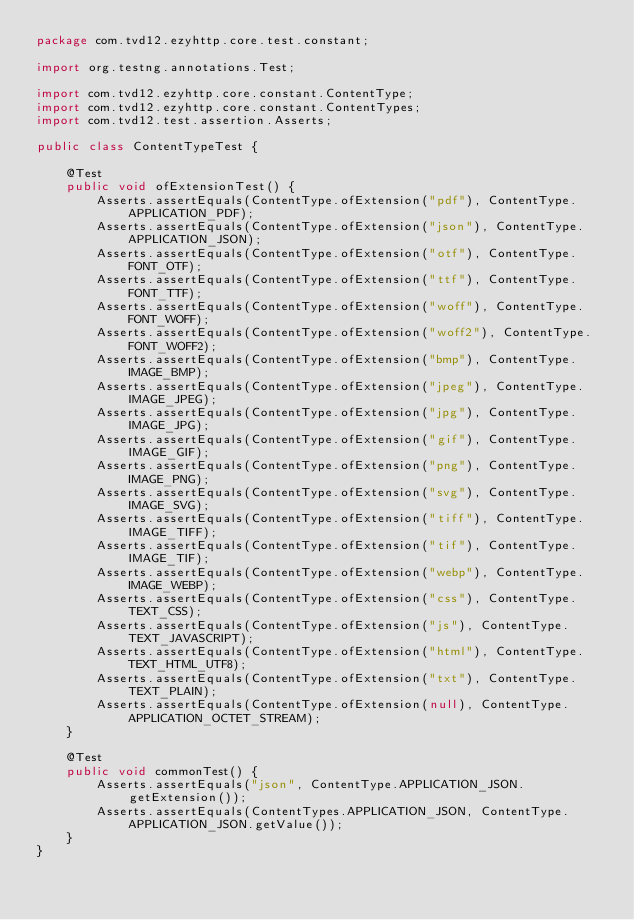Convert code to text. <code><loc_0><loc_0><loc_500><loc_500><_Java_>package com.tvd12.ezyhttp.core.test.constant;

import org.testng.annotations.Test;

import com.tvd12.ezyhttp.core.constant.ContentType;
import com.tvd12.ezyhttp.core.constant.ContentTypes;
import com.tvd12.test.assertion.Asserts;

public class ContentTypeTest {

    @Test
    public void ofExtensionTest() {
        Asserts.assertEquals(ContentType.ofExtension("pdf"), ContentType.APPLICATION_PDF);
        Asserts.assertEquals(ContentType.ofExtension("json"), ContentType.APPLICATION_JSON);
        Asserts.assertEquals(ContentType.ofExtension("otf"), ContentType.FONT_OTF);
        Asserts.assertEquals(ContentType.ofExtension("ttf"), ContentType.FONT_TTF);
        Asserts.assertEquals(ContentType.ofExtension("woff"), ContentType.FONT_WOFF);
        Asserts.assertEquals(ContentType.ofExtension("woff2"), ContentType.FONT_WOFF2);
        Asserts.assertEquals(ContentType.ofExtension("bmp"), ContentType.IMAGE_BMP);
        Asserts.assertEquals(ContentType.ofExtension("jpeg"), ContentType.IMAGE_JPEG);
        Asserts.assertEquals(ContentType.ofExtension("jpg"), ContentType.IMAGE_JPG);
        Asserts.assertEquals(ContentType.ofExtension("gif"), ContentType.IMAGE_GIF);
        Asserts.assertEquals(ContentType.ofExtension("png"), ContentType.IMAGE_PNG);
        Asserts.assertEquals(ContentType.ofExtension("svg"), ContentType.IMAGE_SVG);
        Asserts.assertEquals(ContentType.ofExtension("tiff"), ContentType.IMAGE_TIFF);
        Asserts.assertEquals(ContentType.ofExtension("tif"), ContentType.IMAGE_TIF);
        Asserts.assertEquals(ContentType.ofExtension("webp"), ContentType.IMAGE_WEBP);
        Asserts.assertEquals(ContentType.ofExtension("css"), ContentType.TEXT_CSS);
        Asserts.assertEquals(ContentType.ofExtension("js"), ContentType.TEXT_JAVASCRIPT);
        Asserts.assertEquals(ContentType.ofExtension("html"), ContentType.TEXT_HTML_UTF8);
        Asserts.assertEquals(ContentType.ofExtension("txt"), ContentType.TEXT_PLAIN);
        Asserts.assertEquals(ContentType.ofExtension(null), ContentType.APPLICATION_OCTET_STREAM);
    }

    @Test
    public void commonTest() {
        Asserts.assertEquals("json", ContentType.APPLICATION_JSON.getExtension());
        Asserts.assertEquals(ContentTypes.APPLICATION_JSON, ContentType.APPLICATION_JSON.getValue());
    }
}
</code> 